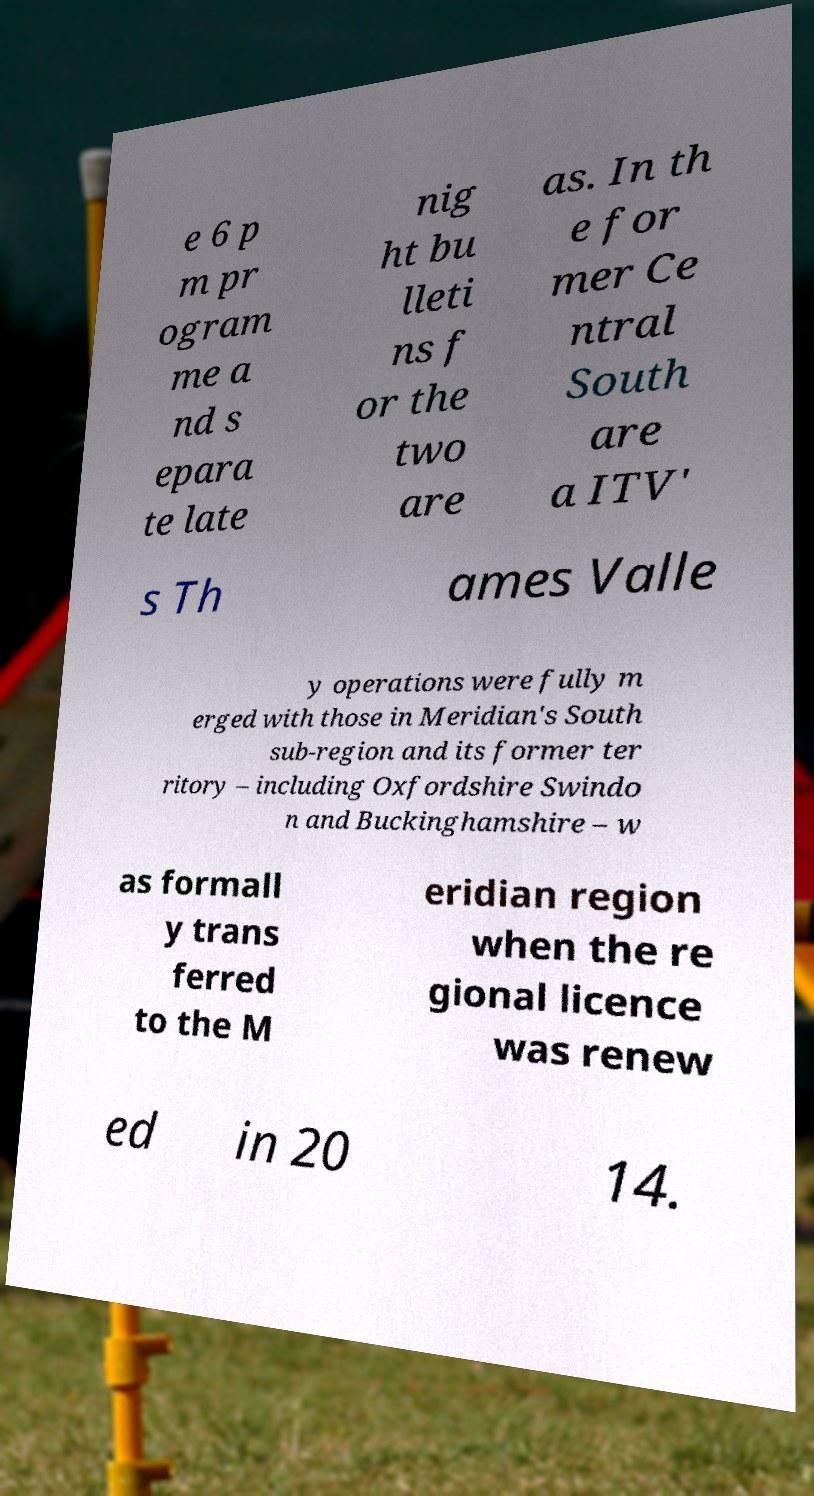Please identify and transcribe the text found in this image. e 6 p m pr ogram me a nd s epara te late nig ht bu lleti ns f or the two are as. In th e for mer Ce ntral South are a ITV' s Th ames Valle y operations were fully m erged with those in Meridian's South sub-region and its former ter ritory – including Oxfordshire Swindo n and Buckinghamshire – w as formall y trans ferred to the M eridian region when the re gional licence was renew ed in 20 14. 